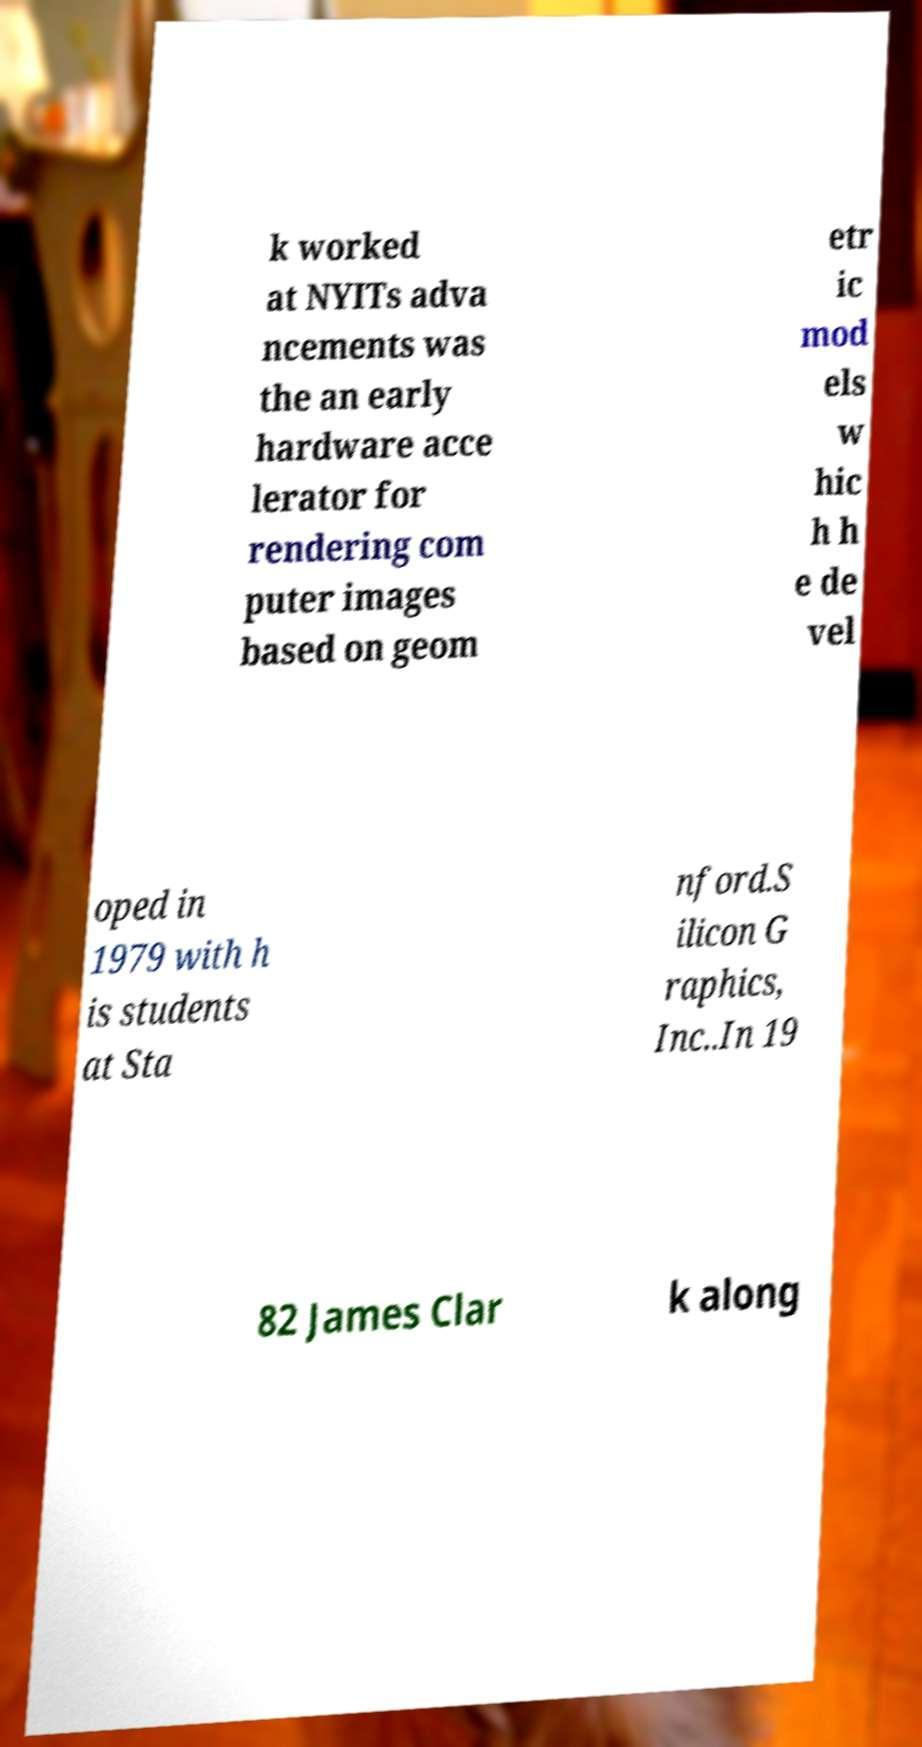Could you assist in decoding the text presented in this image and type it out clearly? k worked at NYITs adva ncements was the an early hardware acce lerator for rendering com puter images based on geom etr ic mod els w hic h h e de vel oped in 1979 with h is students at Sta nford.S ilicon G raphics, Inc..In 19 82 James Clar k along 